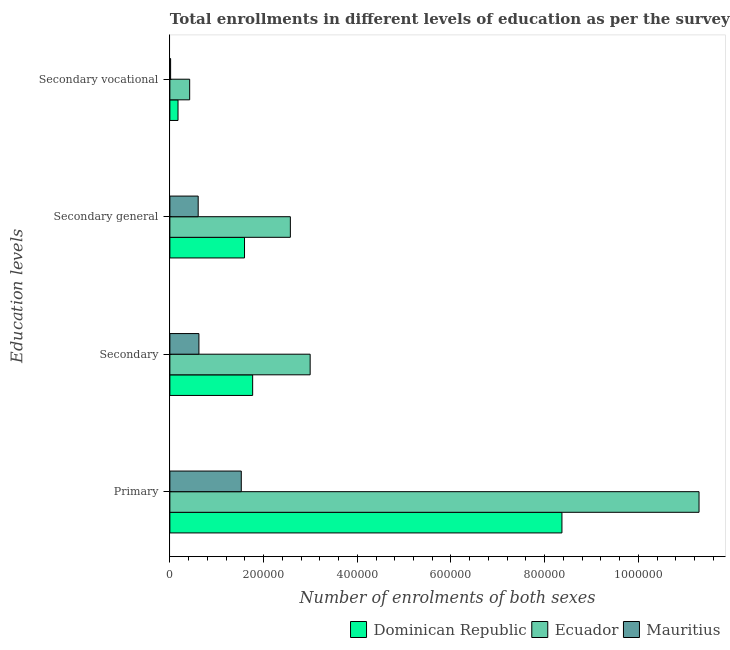How many different coloured bars are there?
Keep it short and to the point. 3. Are the number of bars on each tick of the Y-axis equal?
Give a very brief answer. Yes. What is the label of the 2nd group of bars from the top?
Offer a very short reply. Secondary general. What is the number of enrolments in secondary education in Dominican Republic?
Your answer should be very brief. 1.77e+05. Across all countries, what is the maximum number of enrolments in primary education?
Make the answer very short. 1.13e+06. Across all countries, what is the minimum number of enrolments in secondary education?
Provide a short and direct response. 6.20e+04. In which country was the number of enrolments in secondary general education maximum?
Ensure brevity in your answer.  Ecuador. In which country was the number of enrolments in secondary education minimum?
Your response must be concise. Mauritius. What is the total number of enrolments in secondary education in the graph?
Your answer should be compact. 5.38e+05. What is the difference between the number of enrolments in secondary general education in Ecuador and that in Dominican Republic?
Offer a terse response. 9.78e+04. What is the difference between the number of enrolments in secondary general education in Ecuador and the number of enrolments in secondary vocational education in Dominican Republic?
Provide a short and direct response. 2.40e+05. What is the average number of enrolments in secondary education per country?
Provide a succinct answer. 1.79e+05. What is the difference between the number of enrolments in primary education and number of enrolments in secondary general education in Dominican Republic?
Provide a short and direct response. 6.78e+05. In how many countries, is the number of enrolments in secondary vocational education greater than 360000 ?
Your response must be concise. 0. What is the ratio of the number of enrolments in secondary general education in Ecuador to that in Mauritius?
Give a very brief answer. 4.26. What is the difference between the highest and the second highest number of enrolments in secondary general education?
Offer a very short reply. 9.78e+04. What is the difference between the highest and the lowest number of enrolments in secondary vocational education?
Provide a short and direct response. 4.07e+04. Is the sum of the number of enrolments in secondary vocational education in Dominican Republic and Mauritius greater than the maximum number of enrolments in secondary education across all countries?
Keep it short and to the point. No. Is it the case that in every country, the sum of the number of enrolments in secondary education and number of enrolments in secondary vocational education is greater than the sum of number of enrolments in primary education and number of enrolments in secondary general education?
Offer a very short reply. Yes. What does the 3rd bar from the top in Secondary represents?
Make the answer very short. Dominican Republic. What does the 2nd bar from the bottom in Secondary represents?
Make the answer very short. Ecuador. Is it the case that in every country, the sum of the number of enrolments in primary education and number of enrolments in secondary education is greater than the number of enrolments in secondary general education?
Ensure brevity in your answer.  Yes. Are all the bars in the graph horizontal?
Offer a terse response. Yes. Does the graph contain any zero values?
Your response must be concise. No. Does the graph contain grids?
Ensure brevity in your answer.  No. Where does the legend appear in the graph?
Your response must be concise. Bottom right. How many legend labels are there?
Your answer should be compact. 3. What is the title of the graph?
Provide a short and direct response. Total enrollments in different levels of education as per the survey of 1974. Does "Kuwait" appear as one of the legend labels in the graph?
Ensure brevity in your answer.  No. What is the label or title of the X-axis?
Offer a very short reply. Number of enrolments of both sexes. What is the label or title of the Y-axis?
Offer a terse response. Education levels. What is the Number of enrolments of both sexes in Dominican Republic in Primary?
Your answer should be compact. 8.37e+05. What is the Number of enrolments of both sexes in Ecuador in Primary?
Keep it short and to the point. 1.13e+06. What is the Number of enrolments of both sexes of Mauritius in Primary?
Provide a succinct answer. 1.52e+05. What is the Number of enrolments of both sexes in Dominican Republic in Secondary?
Ensure brevity in your answer.  1.77e+05. What is the Number of enrolments of both sexes in Ecuador in Secondary?
Your response must be concise. 2.99e+05. What is the Number of enrolments of both sexes in Mauritius in Secondary?
Ensure brevity in your answer.  6.20e+04. What is the Number of enrolments of both sexes of Dominican Republic in Secondary general?
Make the answer very short. 1.59e+05. What is the Number of enrolments of both sexes in Ecuador in Secondary general?
Provide a succinct answer. 2.57e+05. What is the Number of enrolments of both sexes in Mauritius in Secondary general?
Your answer should be very brief. 6.04e+04. What is the Number of enrolments of both sexes of Dominican Republic in Secondary vocational?
Your answer should be very brief. 1.74e+04. What is the Number of enrolments of both sexes of Ecuador in Secondary vocational?
Your answer should be very brief. 4.23e+04. What is the Number of enrolments of both sexes of Mauritius in Secondary vocational?
Your answer should be compact. 1574. Across all Education levels, what is the maximum Number of enrolments of both sexes of Dominican Republic?
Your answer should be compact. 8.37e+05. Across all Education levels, what is the maximum Number of enrolments of both sexes of Ecuador?
Your answer should be very brief. 1.13e+06. Across all Education levels, what is the maximum Number of enrolments of both sexes in Mauritius?
Provide a succinct answer. 1.52e+05. Across all Education levels, what is the minimum Number of enrolments of both sexes in Dominican Republic?
Give a very brief answer. 1.74e+04. Across all Education levels, what is the minimum Number of enrolments of both sexes in Ecuador?
Provide a succinct answer. 4.23e+04. Across all Education levels, what is the minimum Number of enrolments of both sexes in Mauritius?
Ensure brevity in your answer.  1574. What is the total Number of enrolments of both sexes in Dominican Republic in the graph?
Provide a succinct answer. 1.19e+06. What is the total Number of enrolments of both sexes of Ecuador in the graph?
Your answer should be very brief. 1.73e+06. What is the total Number of enrolments of both sexes of Mauritius in the graph?
Provide a short and direct response. 2.76e+05. What is the difference between the Number of enrolments of both sexes of Dominican Republic in Primary and that in Secondary?
Provide a short and direct response. 6.60e+05. What is the difference between the Number of enrolments of both sexes in Ecuador in Primary and that in Secondary?
Provide a succinct answer. 8.30e+05. What is the difference between the Number of enrolments of both sexes in Mauritius in Primary and that in Secondary?
Give a very brief answer. 9.04e+04. What is the difference between the Number of enrolments of both sexes in Dominican Republic in Primary and that in Secondary general?
Make the answer very short. 6.78e+05. What is the difference between the Number of enrolments of both sexes of Ecuador in Primary and that in Secondary general?
Offer a very short reply. 8.72e+05. What is the difference between the Number of enrolments of both sexes in Mauritius in Primary and that in Secondary general?
Give a very brief answer. 9.20e+04. What is the difference between the Number of enrolments of both sexes in Dominican Republic in Primary and that in Secondary vocational?
Provide a succinct answer. 8.20e+05. What is the difference between the Number of enrolments of both sexes in Ecuador in Primary and that in Secondary vocational?
Ensure brevity in your answer.  1.09e+06. What is the difference between the Number of enrolments of both sexes in Mauritius in Primary and that in Secondary vocational?
Offer a terse response. 1.51e+05. What is the difference between the Number of enrolments of both sexes in Dominican Republic in Secondary and that in Secondary general?
Give a very brief answer. 1.74e+04. What is the difference between the Number of enrolments of both sexes in Ecuador in Secondary and that in Secondary general?
Make the answer very short. 4.23e+04. What is the difference between the Number of enrolments of both sexes in Mauritius in Secondary and that in Secondary general?
Ensure brevity in your answer.  1574. What is the difference between the Number of enrolments of both sexes of Dominican Republic in Secondary and that in Secondary vocational?
Provide a succinct answer. 1.59e+05. What is the difference between the Number of enrolments of both sexes of Ecuador in Secondary and that in Secondary vocational?
Offer a very short reply. 2.57e+05. What is the difference between the Number of enrolments of both sexes of Mauritius in Secondary and that in Secondary vocational?
Give a very brief answer. 6.04e+04. What is the difference between the Number of enrolments of both sexes of Dominican Republic in Secondary general and that in Secondary vocational?
Provide a short and direct response. 1.42e+05. What is the difference between the Number of enrolments of both sexes of Ecuador in Secondary general and that in Secondary vocational?
Offer a terse response. 2.15e+05. What is the difference between the Number of enrolments of both sexes of Mauritius in Secondary general and that in Secondary vocational?
Provide a short and direct response. 5.89e+04. What is the difference between the Number of enrolments of both sexes of Dominican Republic in Primary and the Number of enrolments of both sexes of Ecuador in Secondary?
Give a very brief answer. 5.37e+05. What is the difference between the Number of enrolments of both sexes in Dominican Republic in Primary and the Number of enrolments of both sexes in Mauritius in Secondary?
Make the answer very short. 7.75e+05. What is the difference between the Number of enrolments of both sexes of Ecuador in Primary and the Number of enrolments of both sexes of Mauritius in Secondary?
Give a very brief answer. 1.07e+06. What is the difference between the Number of enrolments of both sexes in Dominican Republic in Primary and the Number of enrolments of both sexes in Ecuador in Secondary general?
Keep it short and to the point. 5.80e+05. What is the difference between the Number of enrolments of both sexes in Dominican Republic in Primary and the Number of enrolments of both sexes in Mauritius in Secondary general?
Make the answer very short. 7.77e+05. What is the difference between the Number of enrolments of both sexes of Ecuador in Primary and the Number of enrolments of both sexes of Mauritius in Secondary general?
Make the answer very short. 1.07e+06. What is the difference between the Number of enrolments of both sexes of Dominican Republic in Primary and the Number of enrolments of both sexes of Ecuador in Secondary vocational?
Offer a terse response. 7.95e+05. What is the difference between the Number of enrolments of both sexes of Dominican Republic in Primary and the Number of enrolments of both sexes of Mauritius in Secondary vocational?
Offer a terse response. 8.35e+05. What is the difference between the Number of enrolments of both sexes of Ecuador in Primary and the Number of enrolments of both sexes of Mauritius in Secondary vocational?
Ensure brevity in your answer.  1.13e+06. What is the difference between the Number of enrolments of both sexes in Dominican Republic in Secondary and the Number of enrolments of both sexes in Ecuador in Secondary general?
Make the answer very short. -8.05e+04. What is the difference between the Number of enrolments of both sexes of Dominican Republic in Secondary and the Number of enrolments of both sexes of Mauritius in Secondary general?
Your response must be concise. 1.16e+05. What is the difference between the Number of enrolments of both sexes in Ecuador in Secondary and the Number of enrolments of both sexes in Mauritius in Secondary general?
Your answer should be compact. 2.39e+05. What is the difference between the Number of enrolments of both sexes of Dominican Republic in Secondary and the Number of enrolments of both sexes of Ecuador in Secondary vocational?
Offer a very short reply. 1.34e+05. What is the difference between the Number of enrolments of both sexes of Dominican Republic in Secondary and the Number of enrolments of both sexes of Mauritius in Secondary vocational?
Provide a short and direct response. 1.75e+05. What is the difference between the Number of enrolments of both sexes of Ecuador in Secondary and the Number of enrolments of both sexes of Mauritius in Secondary vocational?
Give a very brief answer. 2.98e+05. What is the difference between the Number of enrolments of both sexes in Dominican Republic in Secondary general and the Number of enrolments of both sexes in Ecuador in Secondary vocational?
Your answer should be compact. 1.17e+05. What is the difference between the Number of enrolments of both sexes of Dominican Republic in Secondary general and the Number of enrolments of both sexes of Mauritius in Secondary vocational?
Offer a very short reply. 1.58e+05. What is the difference between the Number of enrolments of both sexes of Ecuador in Secondary general and the Number of enrolments of both sexes of Mauritius in Secondary vocational?
Your answer should be very brief. 2.56e+05. What is the average Number of enrolments of both sexes in Dominican Republic per Education levels?
Give a very brief answer. 2.98e+05. What is the average Number of enrolments of both sexes of Ecuador per Education levels?
Your answer should be very brief. 4.32e+05. What is the average Number of enrolments of both sexes in Mauritius per Education levels?
Offer a very short reply. 6.91e+04. What is the difference between the Number of enrolments of both sexes in Dominican Republic and Number of enrolments of both sexes in Ecuador in Primary?
Your answer should be compact. -2.93e+05. What is the difference between the Number of enrolments of both sexes of Dominican Republic and Number of enrolments of both sexes of Mauritius in Primary?
Provide a succinct answer. 6.85e+05. What is the difference between the Number of enrolments of both sexes of Ecuador and Number of enrolments of both sexes of Mauritius in Primary?
Ensure brevity in your answer.  9.77e+05. What is the difference between the Number of enrolments of both sexes of Dominican Republic and Number of enrolments of both sexes of Ecuador in Secondary?
Keep it short and to the point. -1.23e+05. What is the difference between the Number of enrolments of both sexes in Dominican Republic and Number of enrolments of both sexes in Mauritius in Secondary?
Ensure brevity in your answer.  1.15e+05. What is the difference between the Number of enrolments of both sexes in Ecuador and Number of enrolments of both sexes in Mauritius in Secondary?
Provide a succinct answer. 2.37e+05. What is the difference between the Number of enrolments of both sexes of Dominican Republic and Number of enrolments of both sexes of Ecuador in Secondary general?
Keep it short and to the point. -9.78e+04. What is the difference between the Number of enrolments of both sexes in Dominican Republic and Number of enrolments of both sexes in Mauritius in Secondary general?
Make the answer very short. 9.89e+04. What is the difference between the Number of enrolments of both sexes of Ecuador and Number of enrolments of both sexes of Mauritius in Secondary general?
Offer a terse response. 1.97e+05. What is the difference between the Number of enrolments of both sexes in Dominican Republic and Number of enrolments of both sexes in Ecuador in Secondary vocational?
Ensure brevity in your answer.  -2.49e+04. What is the difference between the Number of enrolments of both sexes of Dominican Republic and Number of enrolments of both sexes of Mauritius in Secondary vocational?
Your response must be concise. 1.58e+04. What is the difference between the Number of enrolments of both sexes in Ecuador and Number of enrolments of both sexes in Mauritius in Secondary vocational?
Keep it short and to the point. 4.07e+04. What is the ratio of the Number of enrolments of both sexes of Dominican Republic in Primary to that in Secondary?
Keep it short and to the point. 4.74. What is the ratio of the Number of enrolments of both sexes of Ecuador in Primary to that in Secondary?
Your response must be concise. 3.77. What is the ratio of the Number of enrolments of both sexes of Mauritius in Primary to that in Secondary?
Ensure brevity in your answer.  2.46. What is the ratio of the Number of enrolments of both sexes in Dominican Republic in Primary to that in Secondary general?
Offer a terse response. 5.25. What is the ratio of the Number of enrolments of both sexes in Ecuador in Primary to that in Secondary general?
Provide a short and direct response. 4.39. What is the ratio of the Number of enrolments of both sexes in Mauritius in Primary to that in Secondary general?
Provide a succinct answer. 2.52. What is the ratio of the Number of enrolments of both sexes in Dominican Republic in Primary to that in Secondary vocational?
Your answer should be very brief. 48.16. What is the ratio of the Number of enrolments of both sexes in Ecuador in Primary to that in Secondary vocational?
Provide a short and direct response. 26.73. What is the ratio of the Number of enrolments of both sexes in Mauritius in Primary to that in Secondary vocational?
Ensure brevity in your answer.  96.83. What is the ratio of the Number of enrolments of both sexes of Dominican Republic in Secondary to that in Secondary general?
Your response must be concise. 1.11. What is the ratio of the Number of enrolments of both sexes in Ecuador in Secondary to that in Secondary general?
Your answer should be compact. 1.16. What is the ratio of the Number of enrolments of both sexes of Mauritius in Secondary to that in Secondary general?
Offer a very short reply. 1.03. What is the ratio of the Number of enrolments of both sexes of Dominican Republic in Secondary to that in Secondary vocational?
Provide a succinct answer. 10.17. What is the ratio of the Number of enrolments of both sexes in Ecuador in Secondary to that in Secondary vocational?
Offer a very short reply. 7.09. What is the ratio of the Number of enrolments of both sexes in Mauritius in Secondary to that in Secondary vocational?
Your answer should be compact. 39.4. What is the ratio of the Number of enrolments of both sexes of Dominican Republic in Secondary general to that in Secondary vocational?
Keep it short and to the point. 9.17. What is the ratio of the Number of enrolments of both sexes of Ecuador in Secondary general to that in Secondary vocational?
Ensure brevity in your answer.  6.09. What is the ratio of the Number of enrolments of both sexes in Mauritius in Secondary general to that in Secondary vocational?
Provide a succinct answer. 38.4. What is the difference between the highest and the second highest Number of enrolments of both sexes of Dominican Republic?
Keep it short and to the point. 6.60e+05. What is the difference between the highest and the second highest Number of enrolments of both sexes in Ecuador?
Your answer should be very brief. 8.30e+05. What is the difference between the highest and the second highest Number of enrolments of both sexes in Mauritius?
Offer a very short reply. 9.04e+04. What is the difference between the highest and the lowest Number of enrolments of both sexes in Dominican Republic?
Keep it short and to the point. 8.20e+05. What is the difference between the highest and the lowest Number of enrolments of both sexes in Ecuador?
Your answer should be very brief. 1.09e+06. What is the difference between the highest and the lowest Number of enrolments of both sexes of Mauritius?
Ensure brevity in your answer.  1.51e+05. 